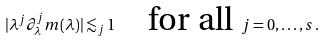<formula> <loc_0><loc_0><loc_500><loc_500>| \lambda ^ { j } \partial _ { \lambda } ^ { j } m ( \lambda ) | \lesssim _ { j } 1 \quad \text {for all} \ j = 0 , \dots , s \, .</formula> 